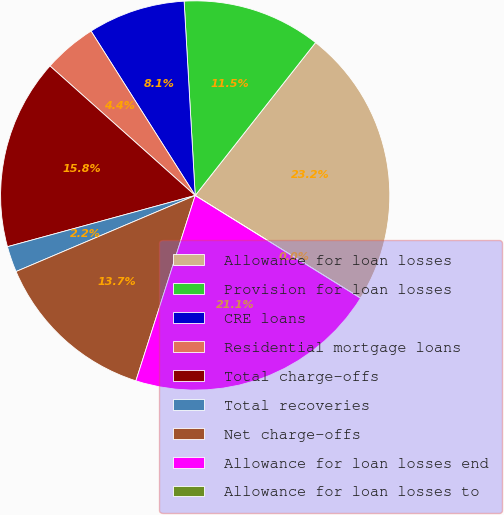Convert chart. <chart><loc_0><loc_0><loc_500><loc_500><pie_chart><fcel>Allowance for loan losses<fcel>Provision for loan losses<fcel>CRE loans<fcel>Residential mortgage loans<fcel>Total charge-offs<fcel>Total recoveries<fcel>Net charge-offs<fcel>Allowance for loan losses end<fcel>Allowance for loan losses to<nl><fcel>23.23%<fcel>11.52%<fcel>8.08%<fcel>4.42%<fcel>15.83%<fcel>2.15%<fcel>13.68%<fcel>21.08%<fcel>0.0%<nl></chart> 